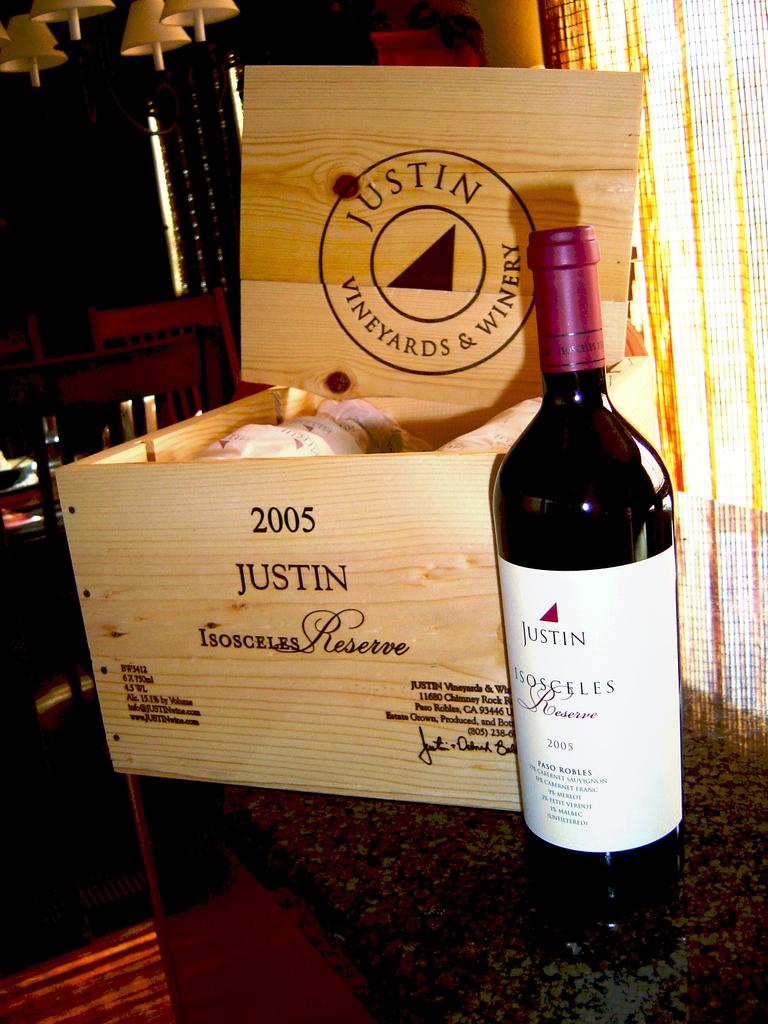What is the name of the wine?
Provide a succinct answer. Justin. 